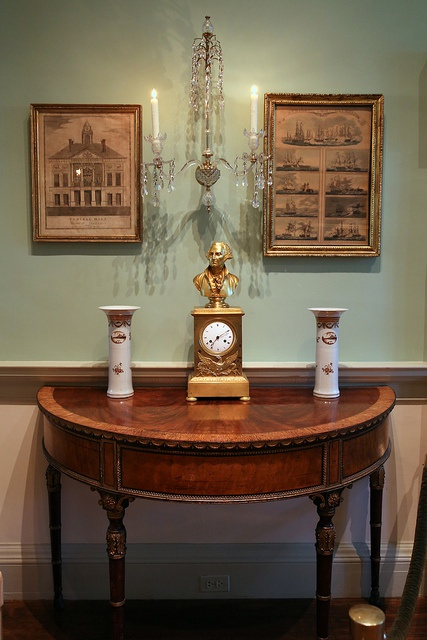Describe the objects in this image and their specific colors. I can see vase in darkgreen, darkgray, gray, and maroon tones, vase in darkgreen, darkgray, gray, and maroon tones, and clock in darkgreen, lightgray, tan, and darkgray tones in this image. 